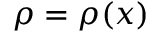<formula> <loc_0><loc_0><loc_500><loc_500>\rho = \rho ( x )</formula> 